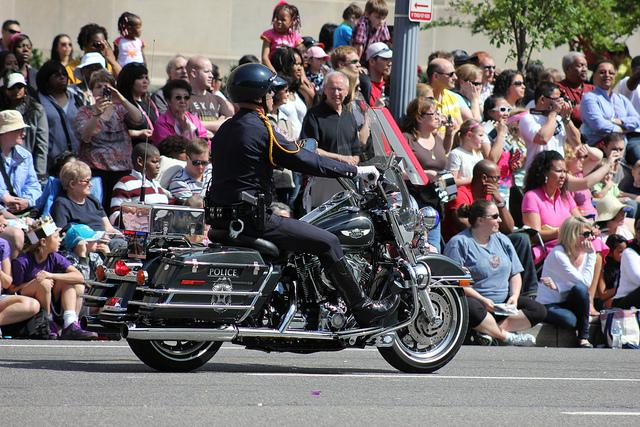Why is the crown worn here? for fun 